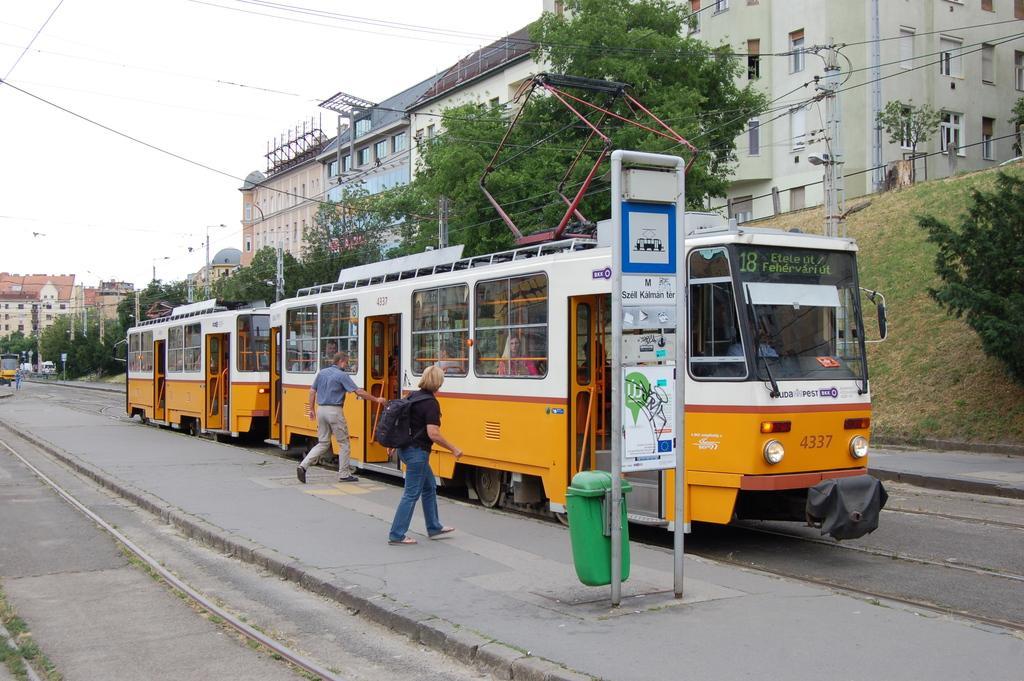Could you give a brief overview of what you see in this image? In this image there is a street train, two persons are boarding into the train, and there is a pole, dustbin, in the background there are trees, buildings and the sky. 